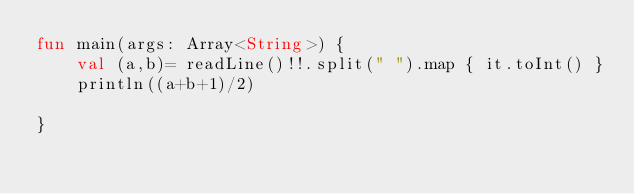<code> <loc_0><loc_0><loc_500><loc_500><_Kotlin_>fun main(args: Array<String>) {
    val (a,b)= readLine()!!.split(" ").map { it.toInt() }
    println((a+b+1)/2)
    
}</code> 